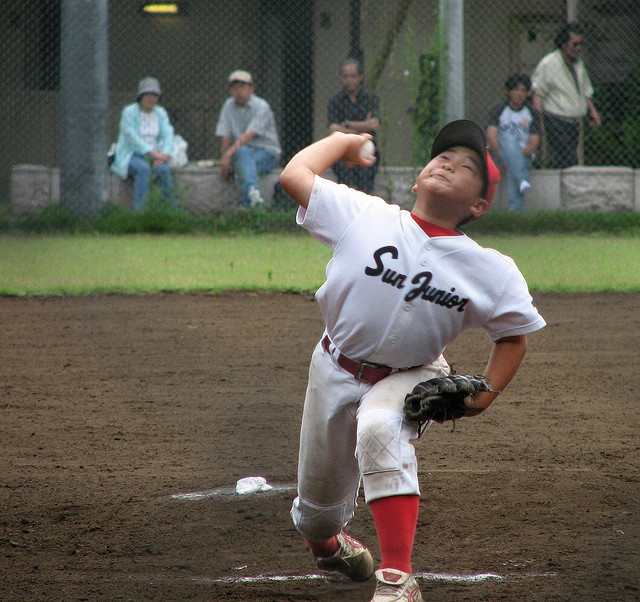Describe the objects in this image and their specific colors. I can see people in black, lavender, gray, and darkgray tones, people in black, darkgray, and gray tones, people in black, gray, and lightblue tones, people in black, gray, and darkgray tones, and people in black and gray tones in this image. 